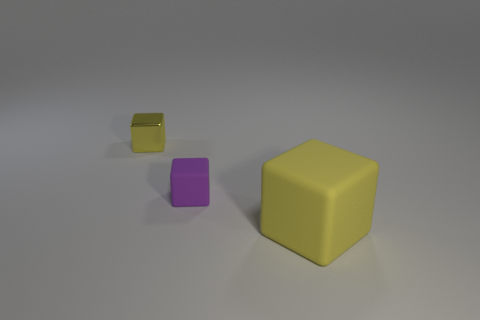Subtract 2 cubes. How many cubes are left? 1 Add 1 large objects. How many objects exist? 4 Subtract all yellow blocks. How many blocks are left? 1 Subtract all yellow rubber blocks. Subtract all small yellow metallic cubes. How many objects are left? 1 Add 3 large matte cubes. How many large matte cubes are left? 4 Add 1 small brown cylinders. How many small brown cylinders exist? 1 Subtract all yellow blocks. How many blocks are left? 1 Subtract 0 green cubes. How many objects are left? 3 Subtract all yellow cubes. Subtract all brown cylinders. How many cubes are left? 1 Subtract all blue spheres. How many purple cubes are left? 1 